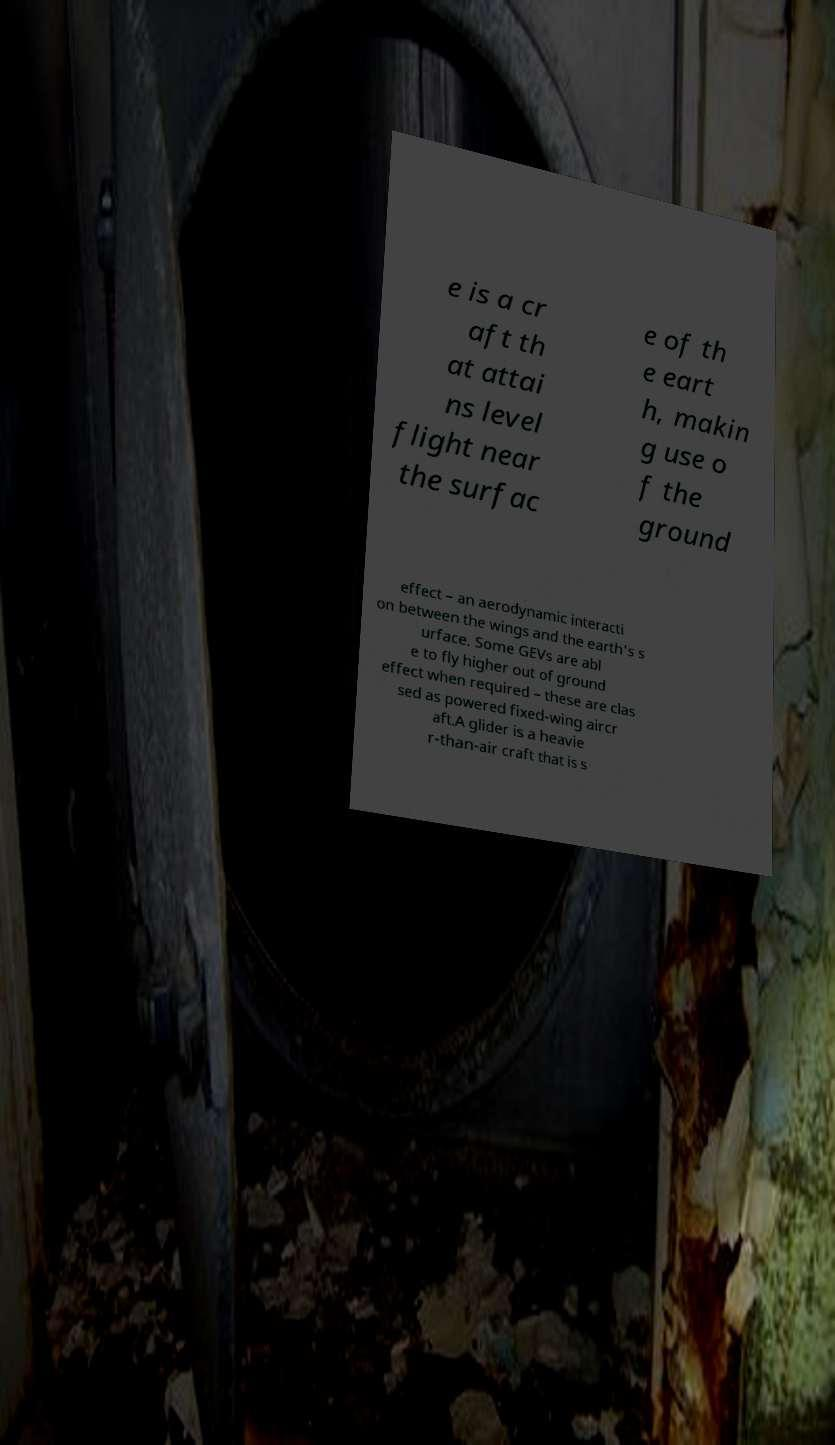There's text embedded in this image that I need extracted. Can you transcribe it verbatim? e is a cr aft th at attai ns level flight near the surfac e of th e eart h, makin g use o f the ground effect – an aerodynamic interacti on between the wings and the earth's s urface. Some GEVs are abl e to fly higher out of ground effect when required – these are clas sed as powered fixed-wing aircr aft.A glider is a heavie r-than-air craft that is s 